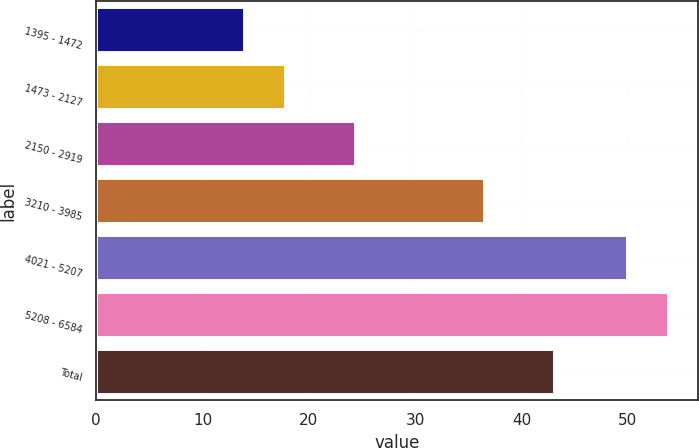Convert chart to OTSL. <chart><loc_0><loc_0><loc_500><loc_500><bar_chart><fcel>1395 - 1472<fcel>1473 - 2127<fcel>2150 - 2919<fcel>3210 - 3985<fcel>4021 - 5207<fcel>5208 - 6584<fcel>Total<nl><fcel>13.95<fcel>17.87<fcel>24.41<fcel>36.58<fcel>49.97<fcel>53.89<fcel>43.16<nl></chart> 